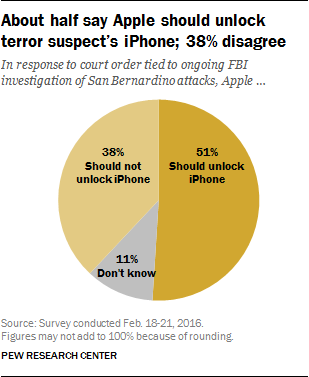Can you tell me more about the survey conducted? Certainly. The survey took place from February 18 to 21, 2016. It reflects the views of the general public during a significant national debate about privacy and security. The results show a division in opinion with a slight majority favoring unlocking the iPhone which may aid in the investigation. 